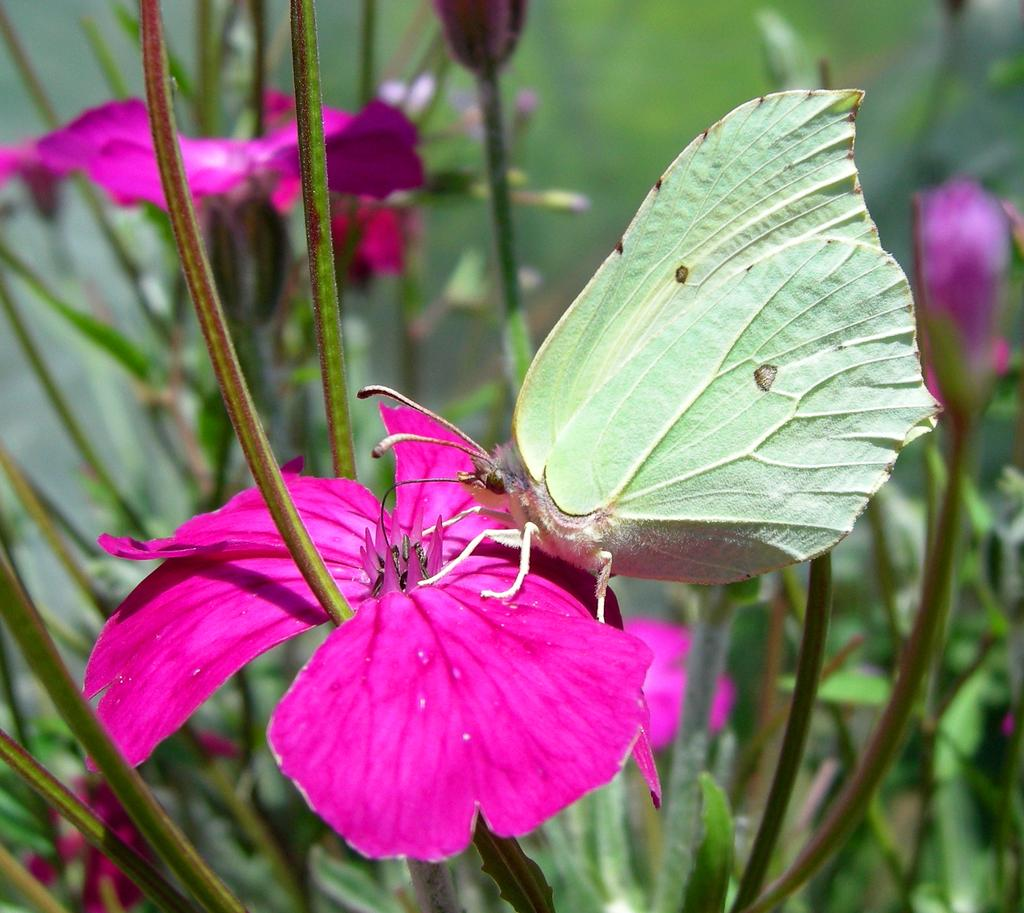What type of plants are visible in the image? There are plants with flowers in the image. Can you describe any specific details about the plants? The plants have flowers, which suggests they are flowering plants. What animal can be seen in the image? There is a butterfly on a flower in the image. How is the background of the image depicted? The background of the image is blurred. What type of lamp is hanging from the tree in the image? There is no lamp present in the image; it features plants and a butterfly. How does the snow affect the appearance of the plants in the image? There is no snow present in the image; it features plants and a butterfly in a non-snowy environment. 